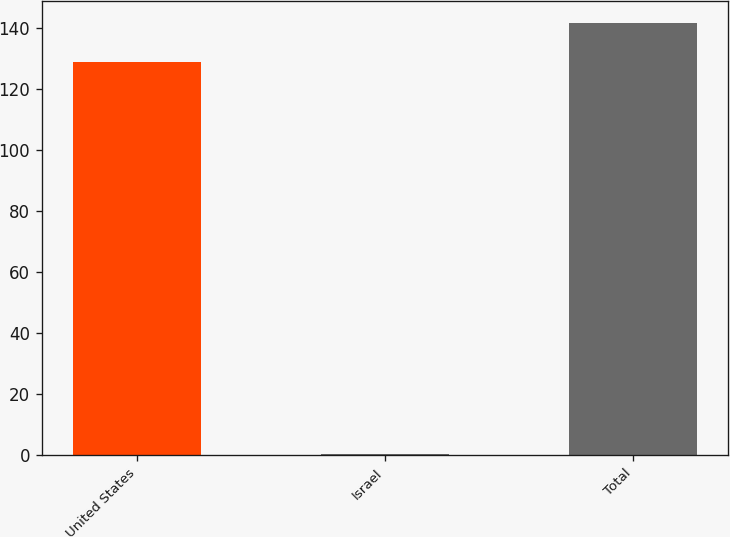<chart> <loc_0><loc_0><loc_500><loc_500><bar_chart><fcel>United States<fcel>Israel<fcel>Total<nl><fcel>128.9<fcel>0.3<fcel>141.79<nl></chart> 